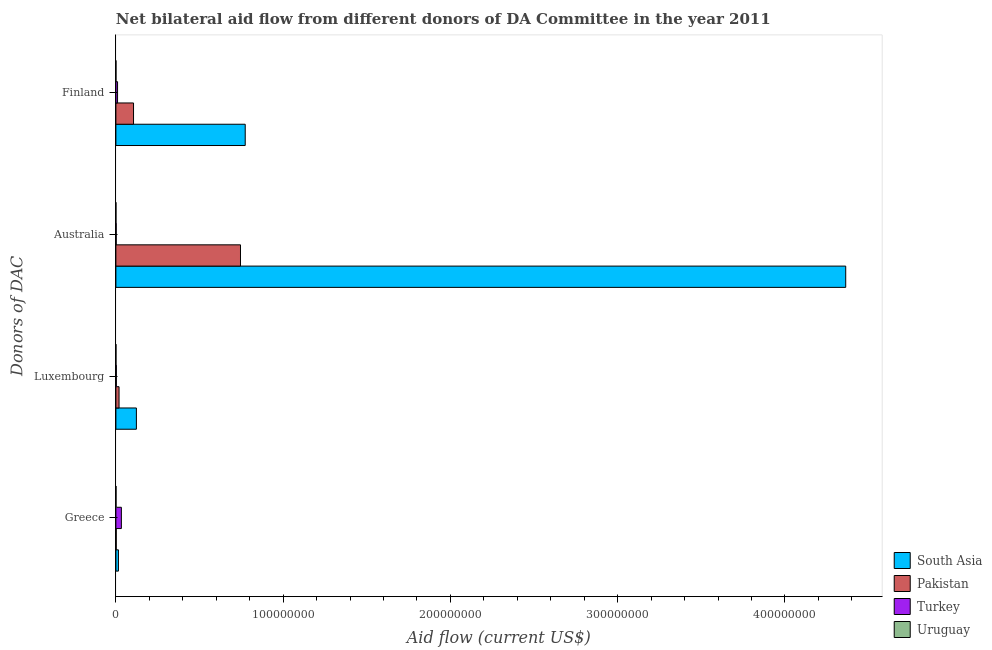Are the number of bars per tick equal to the number of legend labels?
Provide a short and direct response. Yes. What is the label of the 3rd group of bars from the top?
Ensure brevity in your answer.  Luxembourg. What is the amount of aid given by finland in Uruguay?
Offer a very short reply. 5.00e+04. Across all countries, what is the maximum amount of aid given by finland?
Give a very brief answer. 7.73e+07. Across all countries, what is the minimum amount of aid given by greece?
Make the answer very short. 8.00e+04. In which country was the amount of aid given by greece minimum?
Provide a succinct answer. Uruguay. What is the total amount of aid given by luxembourg in the graph?
Keep it short and to the point. 1.45e+07. What is the difference between the amount of aid given by australia in Uruguay and that in South Asia?
Ensure brevity in your answer.  -4.36e+08. What is the difference between the amount of aid given by finland in Turkey and the amount of aid given by australia in Pakistan?
Offer a very short reply. -7.35e+07. What is the average amount of aid given by finland per country?
Your answer should be very brief. 2.22e+07. What is the difference between the amount of aid given by australia and amount of aid given by luxembourg in Pakistan?
Your response must be concise. 7.26e+07. In how many countries, is the amount of aid given by greece greater than 280000000 US$?
Give a very brief answer. 0. What is the ratio of the amount of aid given by australia in South Asia to that in Pakistan?
Give a very brief answer. 5.86. Is the amount of aid given by luxembourg in South Asia less than that in Turkey?
Give a very brief answer. No. What is the difference between the highest and the second highest amount of aid given by australia?
Give a very brief answer. 3.62e+08. What is the difference between the highest and the lowest amount of aid given by australia?
Offer a very short reply. 4.36e+08. Is the sum of the amount of aid given by australia in Uruguay and Turkey greater than the maximum amount of aid given by finland across all countries?
Offer a very short reply. No. Is it the case that in every country, the sum of the amount of aid given by finland and amount of aid given by luxembourg is greater than the sum of amount of aid given by australia and amount of aid given by greece?
Provide a short and direct response. No. What does the 3rd bar from the bottom in Greece represents?
Offer a very short reply. Turkey. Are all the bars in the graph horizontal?
Your answer should be very brief. Yes. Are the values on the major ticks of X-axis written in scientific E-notation?
Your answer should be very brief. No. Does the graph contain grids?
Make the answer very short. No. Where does the legend appear in the graph?
Keep it short and to the point. Bottom right. How many legend labels are there?
Offer a terse response. 4. How are the legend labels stacked?
Your response must be concise. Vertical. What is the title of the graph?
Your answer should be compact. Net bilateral aid flow from different donors of DA Committee in the year 2011. What is the label or title of the Y-axis?
Ensure brevity in your answer.  Donors of DAC. What is the Aid flow (current US$) in South Asia in Greece?
Make the answer very short. 1.52e+06. What is the Aid flow (current US$) of Turkey in Greece?
Provide a short and direct response. 3.28e+06. What is the Aid flow (current US$) in Uruguay in Greece?
Your answer should be very brief. 8.00e+04. What is the Aid flow (current US$) of South Asia in Luxembourg?
Provide a succinct answer. 1.23e+07. What is the Aid flow (current US$) in Pakistan in Luxembourg?
Your answer should be compact. 1.89e+06. What is the Aid flow (current US$) in Uruguay in Luxembourg?
Give a very brief answer. 4.00e+04. What is the Aid flow (current US$) in South Asia in Australia?
Offer a terse response. 4.36e+08. What is the Aid flow (current US$) in Pakistan in Australia?
Ensure brevity in your answer.  7.45e+07. What is the Aid flow (current US$) in Turkey in Australia?
Give a very brief answer. 2.00e+05. What is the Aid flow (current US$) in Uruguay in Australia?
Make the answer very short. 3.00e+04. What is the Aid flow (current US$) in South Asia in Finland?
Your answer should be very brief. 7.73e+07. What is the Aid flow (current US$) in Pakistan in Finland?
Your answer should be compact. 1.06e+07. What is the Aid flow (current US$) in Uruguay in Finland?
Offer a terse response. 5.00e+04. Across all Donors of DAC, what is the maximum Aid flow (current US$) of South Asia?
Your response must be concise. 4.36e+08. Across all Donors of DAC, what is the maximum Aid flow (current US$) in Pakistan?
Your answer should be very brief. 7.45e+07. Across all Donors of DAC, what is the maximum Aid flow (current US$) of Turkey?
Make the answer very short. 3.28e+06. Across all Donors of DAC, what is the maximum Aid flow (current US$) in Uruguay?
Ensure brevity in your answer.  8.00e+04. Across all Donors of DAC, what is the minimum Aid flow (current US$) of South Asia?
Keep it short and to the point. 1.52e+06. Across all Donors of DAC, what is the minimum Aid flow (current US$) of Turkey?
Your answer should be compact. 2.00e+05. Across all Donors of DAC, what is the minimum Aid flow (current US$) in Uruguay?
Your response must be concise. 3.00e+04. What is the total Aid flow (current US$) in South Asia in the graph?
Offer a terse response. 5.27e+08. What is the total Aid flow (current US$) of Pakistan in the graph?
Your answer should be very brief. 8.71e+07. What is the total Aid flow (current US$) in Turkey in the graph?
Keep it short and to the point. 4.76e+06. What is the difference between the Aid flow (current US$) in South Asia in Greece and that in Luxembourg?
Offer a very short reply. -1.07e+07. What is the difference between the Aid flow (current US$) in Pakistan in Greece and that in Luxembourg?
Provide a short and direct response. -1.68e+06. What is the difference between the Aid flow (current US$) of South Asia in Greece and that in Australia?
Keep it short and to the point. -4.35e+08. What is the difference between the Aid flow (current US$) in Pakistan in Greece and that in Australia?
Your response must be concise. -7.43e+07. What is the difference between the Aid flow (current US$) of Turkey in Greece and that in Australia?
Your answer should be compact. 3.08e+06. What is the difference between the Aid flow (current US$) of South Asia in Greece and that in Finland?
Offer a terse response. -7.58e+07. What is the difference between the Aid flow (current US$) in Pakistan in Greece and that in Finland?
Your response must be concise. -1.03e+07. What is the difference between the Aid flow (current US$) of Turkey in Greece and that in Finland?
Your answer should be compact. 2.28e+06. What is the difference between the Aid flow (current US$) of South Asia in Luxembourg and that in Australia?
Give a very brief answer. -4.24e+08. What is the difference between the Aid flow (current US$) in Pakistan in Luxembourg and that in Australia?
Offer a very short reply. -7.26e+07. What is the difference between the Aid flow (current US$) of Uruguay in Luxembourg and that in Australia?
Offer a very short reply. 10000. What is the difference between the Aid flow (current US$) in South Asia in Luxembourg and that in Finland?
Ensure brevity in your answer.  -6.51e+07. What is the difference between the Aid flow (current US$) of Pakistan in Luxembourg and that in Finland?
Your answer should be compact. -8.66e+06. What is the difference between the Aid flow (current US$) of Turkey in Luxembourg and that in Finland?
Make the answer very short. -7.20e+05. What is the difference between the Aid flow (current US$) of South Asia in Australia and that in Finland?
Ensure brevity in your answer.  3.59e+08. What is the difference between the Aid flow (current US$) of Pakistan in Australia and that in Finland?
Give a very brief answer. 6.39e+07. What is the difference between the Aid flow (current US$) in Turkey in Australia and that in Finland?
Offer a very short reply. -8.00e+05. What is the difference between the Aid flow (current US$) in South Asia in Greece and the Aid flow (current US$) in Pakistan in Luxembourg?
Give a very brief answer. -3.70e+05. What is the difference between the Aid flow (current US$) in South Asia in Greece and the Aid flow (current US$) in Turkey in Luxembourg?
Provide a short and direct response. 1.24e+06. What is the difference between the Aid flow (current US$) of South Asia in Greece and the Aid flow (current US$) of Uruguay in Luxembourg?
Provide a short and direct response. 1.48e+06. What is the difference between the Aid flow (current US$) in Pakistan in Greece and the Aid flow (current US$) in Uruguay in Luxembourg?
Make the answer very short. 1.70e+05. What is the difference between the Aid flow (current US$) of Turkey in Greece and the Aid flow (current US$) of Uruguay in Luxembourg?
Your response must be concise. 3.24e+06. What is the difference between the Aid flow (current US$) in South Asia in Greece and the Aid flow (current US$) in Pakistan in Australia?
Your answer should be very brief. -7.30e+07. What is the difference between the Aid flow (current US$) in South Asia in Greece and the Aid flow (current US$) in Turkey in Australia?
Keep it short and to the point. 1.32e+06. What is the difference between the Aid flow (current US$) of South Asia in Greece and the Aid flow (current US$) of Uruguay in Australia?
Ensure brevity in your answer.  1.49e+06. What is the difference between the Aid flow (current US$) in Pakistan in Greece and the Aid flow (current US$) in Uruguay in Australia?
Provide a short and direct response. 1.80e+05. What is the difference between the Aid flow (current US$) in Turkey in Greece and the Aid flow (current US$) in Uruguay in Australia?
Your answer should be compact. 3.25e+06. What is the difference between the Aid flow (current US$) in South Asia in Greece and the Aid flow (current US$) in Pakistan in Finland?
Offer a terse response. -9.03e+06. What is the difference between the Aid flow (current US$) in South Asia in Greece and the Aid flow (current US$) in Turkey in Finland?
Your answer should be compact. 5.20e+05. What is the difference between the Aid flow (current US$) in South Asia in Greece and the Aid flow (current US$) in Uruguay in Finland?
Provide a short and direct response. 1.47e+06. What is the difference between the Aid flow (current US$) of Pakistan in Greece and the Aid flow (current US$) of Turkey in Finland?
Your response must be concise. -7.90e+05. What is the difference between the Aid flow (current US$) of Pakistan in Greece and the Aid flow (current US$) of Uruguay in Finland?
Your answer should be very brief. 1.60e+05. What is the difference between the Aid flow (current US$) of Turkey in Greece and the Aid flow (current US$) of Uruguay in Finland?
Keep it short and to the point. 3.23e+06. What is the difference between the Aid flow (current US$) of South Asia in Luxembourg and the Aid flow (current US$) of Pakistan in Australia?
Your answer should be compact. -6.22e+07. What is the difference between the Aid flow (current US$) in South Asia in Luxembourg and the Aid flow (current US$) in Turkey in Australia?
Offer a terse response. 1.21e+07. What is the difference between the Aid flow (current US$) of South Asia in Luxembourg and the Aid flow (current US$) of Uruguay in Australia?
Make the answer very short. 1.22e+07. What is the difference between the Aid flow (current US$) of Pakistan in Luxembourg and the Aid flow (current US$) of Turkey in Australia?
Give a very brief answer. 1.69e+06. What is the difference between the Aid flow (current US$) of Pakistan in Luxembourg and the Aid flow (current US$) of Uruguay in Australia?
Give a very brief answer. 1.86e+06. What is the difference between the Aid flow (current US$) in Turkey in Luxembourg and the Aid flow (current US$) in Uruguay in Australia?
Provide a short and direct response. 2.50e+05. What is the difference between the Aid flow (current US$) of South Asia in Luxembourg and the Aid flow (current US$) of Pakistan in Finland?
Offer a terse response. 1.71e+06. What is the difference between the Aid flow (current US$) of South Asia in Luxembourg and the Aid flow (current US$) of Turkey in Finland?
Your answer should be very brief. 1.13e+07. What is the difference between the Aid flow (current US$) of South Asia in Luxembourg and the Aid flow (current US$) of Uruguay in Finland?
Your answer should be very brief. 1.22e+07. What is the difference between the Aid flow (current US$) in Pakistan in Luxembourg and the Aid flow (current US$) in Turkey in Finland?
Provide a short and direct response. 8.90e+05. What is the difference between the Aid flow (current US$) in Pakistan in Luxembourg and the Aid flow (current US$) in Uruguay in Finland?
Make the answer very short. 1.84e+06. What is the difference between the Aid flow (current US$) in Turkey in Luxembourg and the Aid flow (current US$) in Uruguay in Finland?
Your response must be concise. 2.30e+05. What is the difference between the Aid flow (current US$) of South Asia in Australia and the Aid flow (current US$) of Pakistan in Finland?
Your answer should be very brief. 4.26e+08. What is the difference between the Aid flow (current US$) of South Asia in Australia and the Aid flow (current US$) of Turkey in Finland?
Give a very brief answer. 4.35e+08. What is the difference between the Aid flow (current US$) of South Asia in Australia and the Aid flow (current US$) of Uruguay in Finland?
Offer a very short reply. 4.36e+08. What is the difference between the Aid flow (current US$) of Pakistan in Australia and the Aid flow (current US$) of Turkey in Finland?
Your answer should be compact. 7.35e+07. What is the difference between the Aid flow (current US$) in Pakistan in Australia and the Aid flow (current US$) in Uruguay in Finland?
Offer a very short reply. 7.44e+07. What is the average Aid flow (current US$) of South Asia per Donors of DAC?
Your answer should be very brief. 1.32e+08. What is the average Aid flow (current US$) of Pakistan per Donors of DAC?
Provide a succinct answer. 2.18e+07. What is the average Aid flow (current US$) in Turkey per Donors of DAC?
Give a very brief answer. 1.19e+06. What is the average Aid flow (current US$) of Uruguay per Donors of DAC?
Make the answer very short. 5.00e+04. What is the difference between the Aid flow (current US$) of South Asia and Aid flow (current US$) of Pakistan in Greece?
Ensure brevity in your answer.  1.31e+06. What is the difference between the Aid flow (current US$) in South Asia and Aid flow (current US$) in Turkey in Greece?
Your answer should be very brief. -1.76e+06. What is the difference between the Aid flow (current US$) of South Asia and Aid flow (current US$) of Uruguay in Greece?
Give a very brief answer. 1.44e+06. What is the difference between the Aid flow (current US$) of Pakistan and Aid flow (current US$) of Turkey in Greece?
Offer a terse response. -3.07e+06. What is the difference between the Aid flow (current US$) of Turkey and Aid flow (current US$) of Uruguay in Greece?
Your answer should be compact. 3.20e+06. What is the difference between the Aid flow (current US$) in South Asia and Aid flow (current US$) in Pakistan in Luxembourg?
Your answer should be very brief. 1.04e+07. What is the difference between the Aid flow (current US$) in South Asia and Aid flow (current US$) in Turkey in Luxembourg?
Offer a very short reply. 1.20e+07. What is the difference between the Aid flow (current US$) of South Asia and Aid flow (current US$) of Uruguay in Luxembourg?
Ensure brevity in your answer.  1.22e+07. What is the difference between the Aid flow (current US$) of Pakistan and Aid flow (current US$) of Turkey in Luxembourg?
Ensure brevity in your answer.  1.61e+06. What is the difference between the Aid flow (current US$) of Pakistan and Aid flow (current US$) of Uruguay in Luxembourg?
Give a very brief answer. 1.85e+06. What is the difference between the Aid flow (current US$) in South Asia and Aid flow (current US$) in Pakistan in Australia?
Offer a very short reply. 3.62e+08. What is the difference between the Aid flow (current US$) of South Asia and Aid flow (current US$) of Turkey in Australia?
Make the answer very short. 4.36e+08. What is the difference between the Aid flow (current US$) in South Asia and Aid flow (current US$) in Uruguay in Australia?
Offer a very short reply. 4.36e+08. What is the difference between the Aid flow (current US$) in Pakistan and Aid flow (current US$) in Turkey in Australia?
Provide a short and direct response. 7.43e+07. What is the difference between the Aid flow (current US$) in Pakistan and Aid flow (current US$) in Uruguay in Australia?
Provide a short and direct response. 7.45e+07. What is the difference between the Aid flow (current US$) of Turkey and Aid flow (current US$) of Uruguay in Australia?
Offer a terse response. 1.70e+05. What is the difference between the Aid flow (current US$) of South Asia and Aid flow (current US$) of Pakistan in Finland?
Ensure brevity in your answer.  6.68e+07. What is the difference between the Aid flow (current US$) in South Asia and Aid flow (current US$) in Turkey in Finland?
Ensure brevity in your answer.  7.63e+07. What is the difference between the Aid flow (current US$) of South Asia and Aid flow (current US$) of Uruguay in Finland?
Keep it short and to the point. 7.73e+07. What is the difference between the Aid flow (current US$) in Pakistan and Aid flow (current US$) in Turkey in Finland?
Your answer should be very brief. 9.55e+06. What is the difference between the Aid flow (current US$) of Pakistan and Aid flow (current US$) of Uruguay in Finland?
Give a very brief answer. 1.05e+07. What is the difference between the Aid flow (current US$) in Turkey and Aid flow (current US$) in Uruguay in Finland?
Provide a short and direct response. 9.50e+05. What is the ratio of the Aid flow (current US$) in South Asia in Greece to that in Luxembourg?
Give a very brief answer. 0.12. What is the ratio of the Aid flow (current US$) in Turkey in Greece to that in Luxembourg?
Offer a terse response. 11.71. What is the ratio of the Aid flow (current US$) in Uruguay in Greece to that in Luxembourg?
Give a very brief answer. 2. What is the ratio of the Aid flow (current US$) of South Asia in Greece to that in Australia?
Your answer should be compact. 0. What is the ratio of the Aid flow (current US$) in Pakistan in Greece to that in Australia?
Ensure brevity in your answer.  0. What is the ratio of the Aid flow (current US$) in Turkey in Greece to that in Australia?
Your answer should be very brief. 16.4. What is the ratio of the Aid flow (current US$) in Uruguay in Greece to that in Australia?
Keep it short and to the point. 2.67. What is the ratio of the Aid flow (current US$) in South Asia in Greece to that in Finland?
Your answer should be compact. 0.02. What is the ratio of the Aid flow (current US$) in Pakistan in Greece to that in Finland?
Provide a succinct answer. 0.02. What is the ratio of the Aid flow (current US$) in Turkey in Greece to that in Finland?
Provide a succinct answer. 3.28. What is the ratio of the Aid flow (current US$) in South Asia in Luxembourg to that in Australia?
Make the answer very short. 0.03. What is the ratio of the Aid flow (current US$) of Pakistan in Luxembourg to that in Australia?
Offer a very short reply. 0.03. What is the ratio of the Aid flow (current US$) in South Asia in Luxembourg to that in Finland?
Your response must be concise. 0.16. What is the ratio of the Aid flow (current US$) of Pakistan in Luxembourg to that in Finland?
Your answer should be very brief. 0.18. What is the ratio of the Aid flow (current US$) in Turkey in Luxembourg to that in Finland?
Your response must be concise. 0.28. What is the ratio of the Aid flow (current US$) of South Asia in Australia to that in Finland?
Your response must be concise. 5.64. What is the ratio of the Aid flow (current US$) in Pakistan in Australia to that in Finland?
Your answer should be very brief. 7.06. What is the ratio of the Aid flow (current US$) in Turkey in Australia to that in Finland?
Your answer should be compact. 0.2. What is the difference between the highest and the second highest Aid flow (current US$) of South Asia?
Ensure brevity in your answer.  3.59e+08. What is the difference between the highest and the second highest Aid flow (current US$) in Pakistan?
Keep it short and to the point. 6.39e+07. What is the difference between the highest and the second highest Aid flow (current US$) of Turkey?
Provide a succinct answer. 2.28e+06. What is the difference between the highest and the second highest Aid flow (current US$) in Uruguay?
Your answer should be compact. 3.00e+04. What is the difference between the highest and the lowest Aid flow (current US$) of South Asia?
Provide a succinct answer. 4.35e+08. What is the difference between the highest and the lowest Aid flow (current US$) in Pakistan?
Offer a very short reply. 7.43e+07. What is the difference between the highest and the lowest Aid flow (current US$) in Turkey?
Your answer should be very brief. 3.08e+06. 